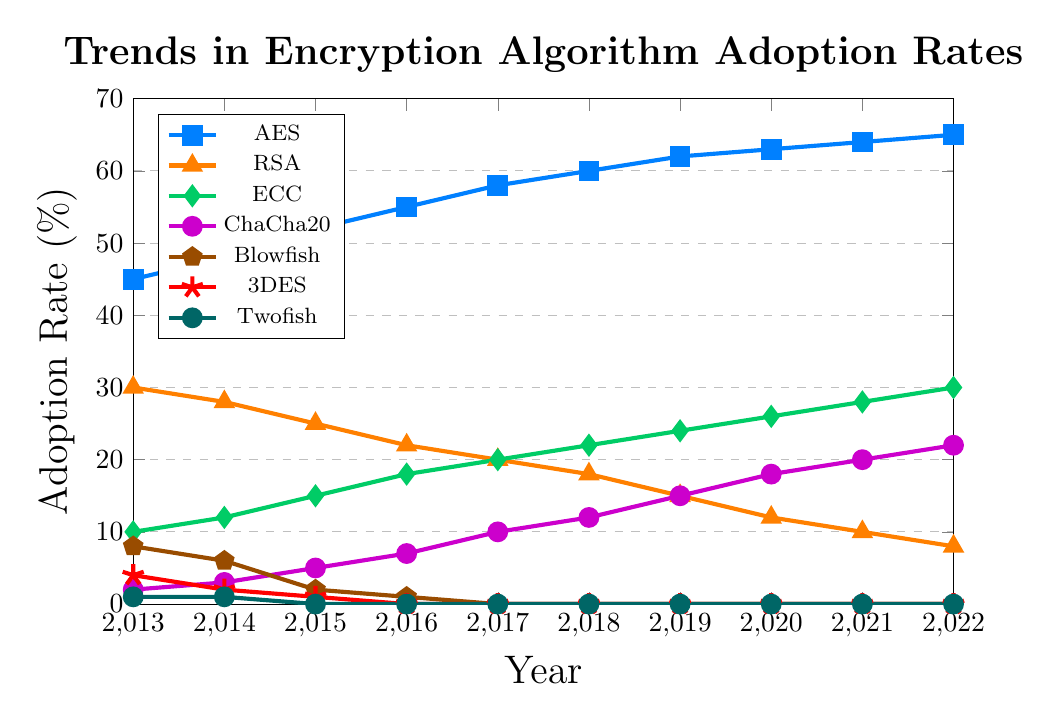What encryption algorithm had the highest adoption rate in 2022? We need to look at the 2022 data points for each encryption algorithm and identify which one has the highest value. AES has the highest value at 65%.
Answer: AES Which encryption algorithm saw the most significant decline in adoption rates from 2013 to 2022? We need to calculate the difference in adoption rates from 2013 to 2022 for each algorithm and identify which one has the largest negative change. Blowfish declined from 8% in 2013 to 0% in 2022, a decline of 8 percentage points.
Answer: Blowfish How did the adoption rate of AES change from 2013 to 2019? To determine the change, subtract the 2013 adoption rate from the 2019 adoption rate. In 2013, AES was at 45%, and in 2019, it was at 62%, so the change is 62% - 45% = 17%.
Answer: Increased by 17% Which algorithm had a faster increase in adoption from 2016 to 2022: ECC or ChaCha20? To determine this, compute the adoption rate change for ECC and ChaCha20 from 2016 to 2022 and compare them. ECC increased from 18% to 30%, a 12 percentage point increase; ChaCha20 increased from 7% to 22%, a 15 percentage point increase.
Answer: ChaCha20 What is the overall trend in the adoption of 3DES over the past decade? By observing the line for 3DES, we can see it starts at 4% in 2013 and drops to 0% from 2016 onward, showing a continued decline to zero.
Answer: Decreasing Which year did ECC and RSA have equal adoption rates? By observing the two lines, we can see that in 2017, both ECC and RSA had an adoption rate of 20%.
Answer: 2017 What is the combined adoption rate of AES and ChaCha20 in 2022? We need to add the adoption rates of AES and ChaCha20 in 2022. AES is at 65% and ChaCha20 is at 22%, so combined they are 65% + 22% = 87%.
Answer: 87% Which two algorithms have shown a consistent increase in adoption rates over the entire period from 2013 to 2022? By observing the lines, ECC and ChaCha20 show a consistent increase every year with no declines.
Answer: ECC and ChaCha20 When did Blowfish fall to an adoption rate of 0%? By observing the line for Blowfish, it falls to 0% in 2017 and stays there afterward.
Answer: 2017 Among all the algorithms, which one had the smallest initial adoption rate in 2013, and what was that rate? By looking at the 2013 data points, Twofish had the smallest initial adoption rate at 1%.
Answer: Twofish, 1% 